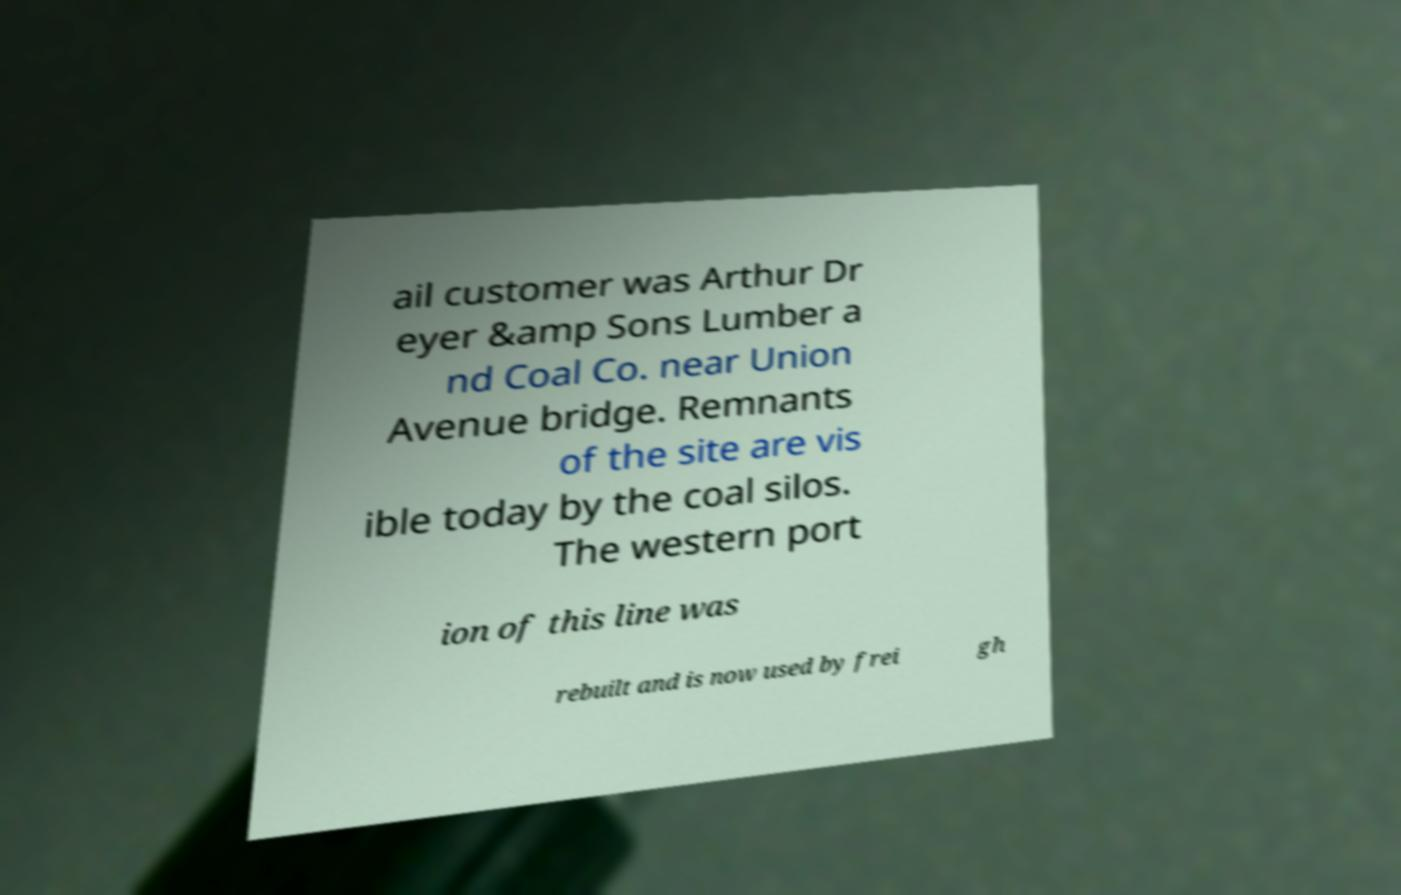Can you read and provide the text displayed in the image?This photo seems to have some interesting text. Can you extract and type it out for me? ail customer was Arthur Dr eyer &amp Sons Lumber a nd Coal Co. near Union Avenue bridge. Remnants of the site are vis ible today by the coal silos. The western port ion of this line was rebuilt and is now used by frei gh 